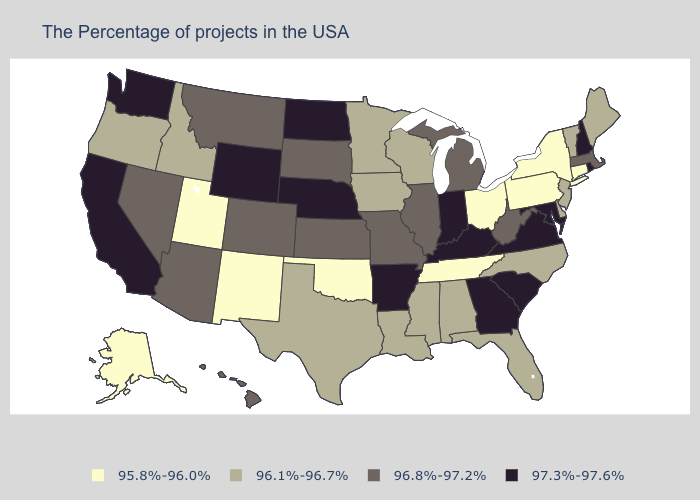Does Nevada have the lowest value in the West?
Give a very brief answer. No. Is the legend a continuous bar?
Concise answer only. No. What is the lowest value in the MidWest?
Be succinct. 95.8%-96.0%. Does Maryland have the lowest value in the USA?
Quick response, please. No. What is the highest value in the South ?
Keep it brief. 97.3%-97.6%. What is the value of Florida?
Give a very brief answer. 96.1%-96.7%. What is the lowest value in the West?
Answer briefly. 95.8%-96.0%. Name the states that have a value in the range 96.8%-97.2%?
Concise answer only. Massachusetts, West Virginia, Michigan, Illinois, Missouri, Kansas, South Dakota, Colorado, Montana, Arizona, Nevada, Hawaii. What is the value of Mississippi?
Concise answer only. 96.1%-96.7%. Name the states that have a value in the range 96.1%-96.7%?
Keep it brief. Maine, Vermont, New Jersey, Delaware, North Carolina, Florida, Alabama, Wisconsin, Mississippi, Louisiana, Minnesota, Iowa, Texas, Idaho, Oregon. Does Arizona have the lowest value in the West?
Keep it brief. No. Which states hav the highest value in the Northeast?
Write a very short answer. Rhode Island, New Hampshire. What is the value of Arkansas?
Be succinct. 97.3%-97.6%. Name the states that have a value in the range 96.1%-96.7%?
Be succinct. Maine, Vermont, New Jersey, Delaware, North Carolina, Florida, Alabama, Wisconsin, Mississippi, Louisiana, Minnesota, Iowa, Texas, Idaho, Oregon. Does Arizona have a lower value than Georgia?
Concise answer only. Yes. 